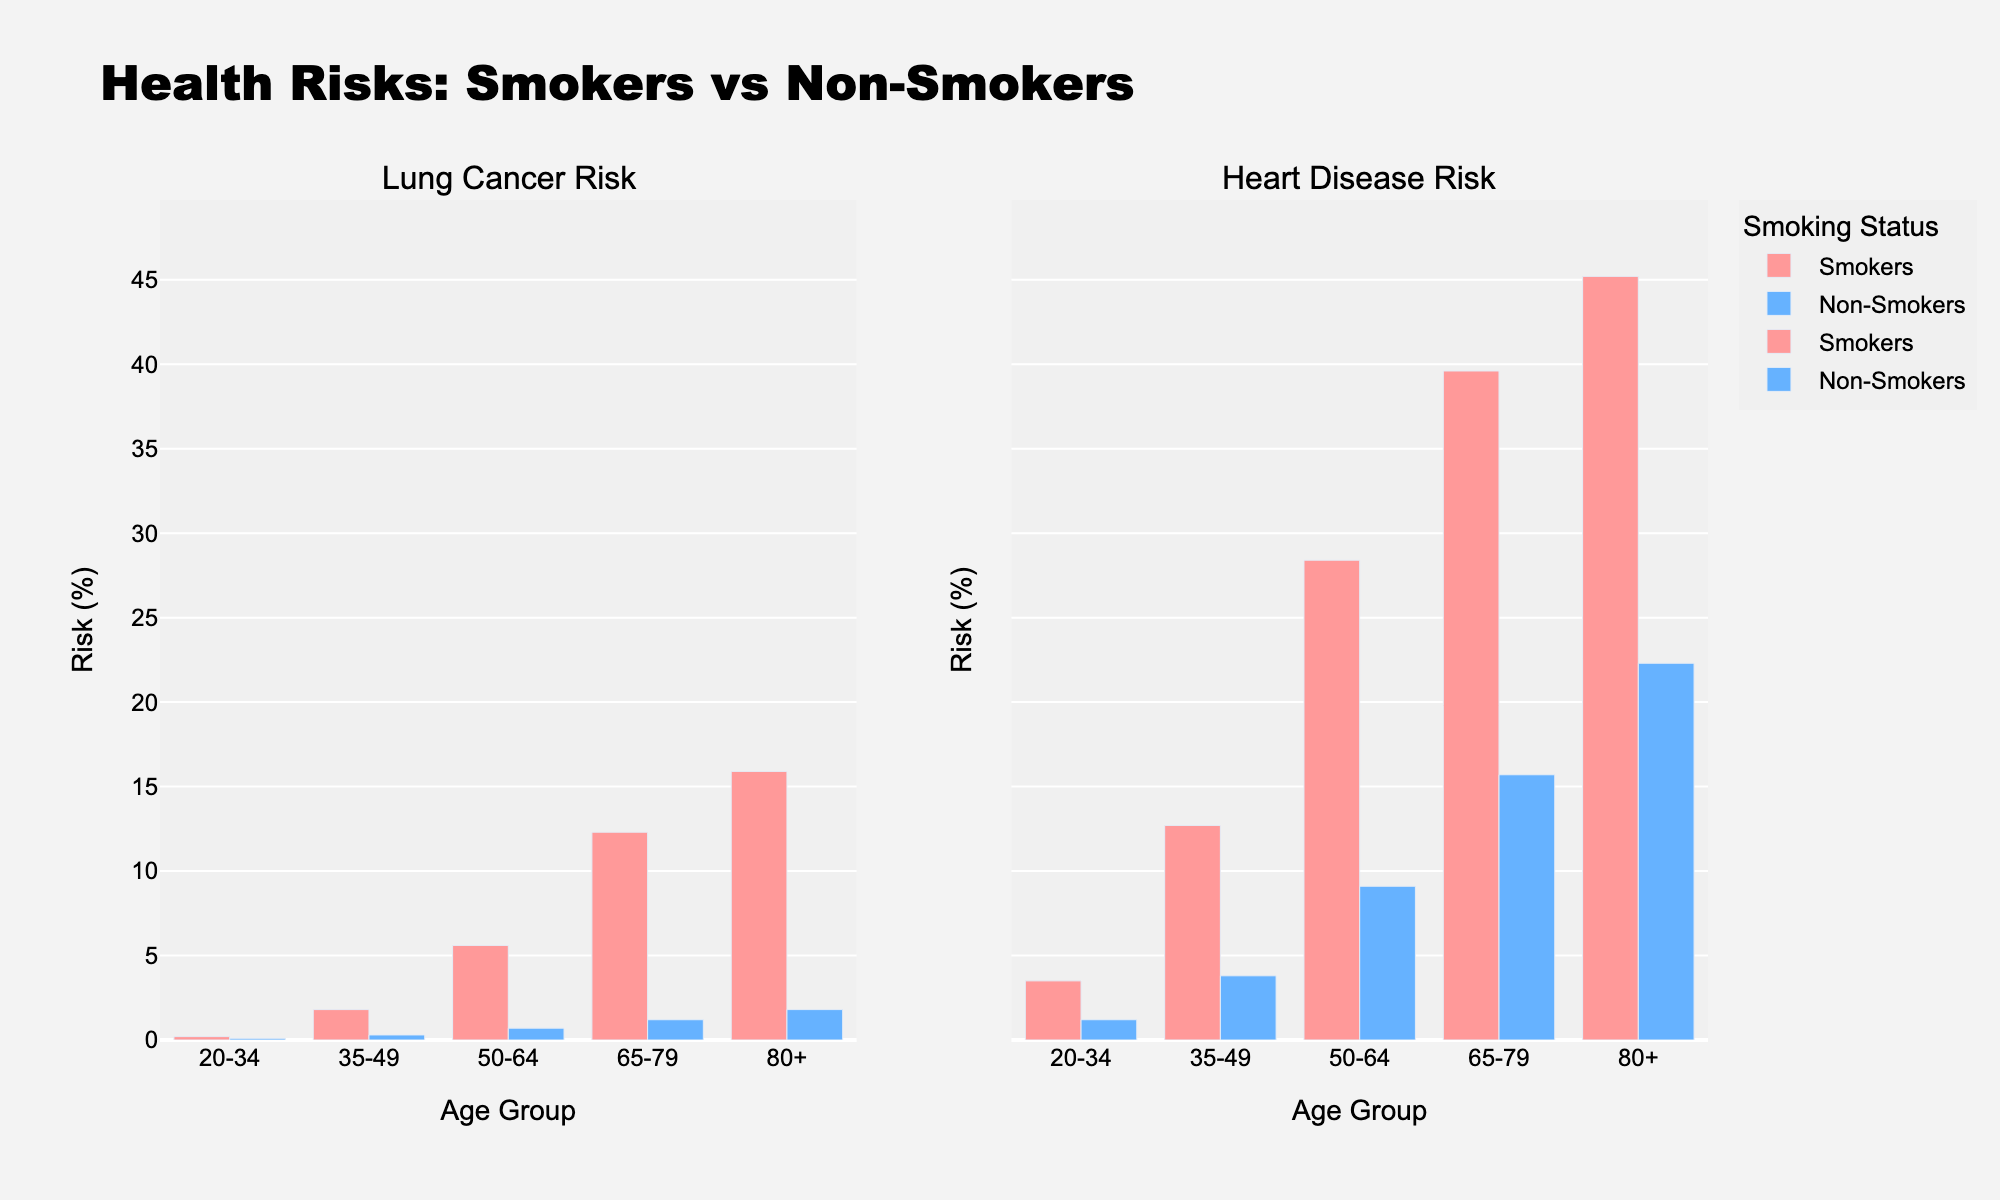what is the lung cancer risk percentage for smokers aged 50-64? Look at the bar chart in the "Lung Cancer Risk" section and find the bar corresponding to smokers in the 50-64 age group.
Answer: 5.6% which age group has the highest heart disease risk among non-smokers? Look at the bar chart in the "Heart Disease Risk" section and find out which bar has the tallest height for non-smokers.
Answer: 80+ how much greater is the lung cancer risk for smokers compared to non-smokers in the 35-49 age group? Check the height of the bars in the "Lung Cancer Risk" section for the 35-49 age group. Subtract the height of the non-smokers' bar from the height of the smokers' bar: 1.8% - 0.3% = 1.5%.
Answer: 1.5% what color represents smokers in the bar chart? Look at the legend in the chart to see which color is designated for smokers.
Answer: Red compare the heart disease risk for smokers aged 20-34 with the lung cancer risk for non-smokers aged 80+. What is the difference? Find the bar heights: For smokers aged 20-34 in the "Heart Disease Risk" section, it's 3.5%. For non-smokers aged 80+ in the "Lung Cancer Risk" section, it's 1.8%. Calculate the difference: 3.5% - 1.8% = 1.7%.
Answer: 1.7% which health risk is more affected by smoking in the 65-79 age group, lung cancer, or heart disease? Compare the difference in the heights of the bars for smokers and non-smokers in the "Lung Cancer Risk" and "Heart Disease Risk" sections for the 65-79 age group. The difference in lung cancer risk: 12.3% - 1.2% = 11.1%. The difference in heart disease risk: 39.6% - 15.7% = 23.9%. The heart disease risk is more affected.
Answer: Heart disease what is the overall trend in lung cancer risk for smokers as age increases? Observe the height of the bars for smokers in the "Lung Cancer Risk" section from the youngest to the oldest age group. The heights increase, indicating that risk rises with age.
Answer: Increases how many more times is the lung cancer risk for smokers compared to non-smokers in the age group 80+? Find the bar heights for the 80+ age group in the "Lung Cancer Risk" section: 15.9% for smokers and 1.8% for non-smokers. Divide 15.9 by 1.8 to get approximately 8.83 times.
Answer: 8.83 by how much does the heart disease risk for non-smokers increase from the 20-34 to the 50-64 age group? Find the heights of the bars for non-smokers in the "Heart Disease Risk" section for the 20-34 and 50-64 age groups. Calculate the difference: 9.1% - 1.2% = 7.9%.
Answer: 7.9% 